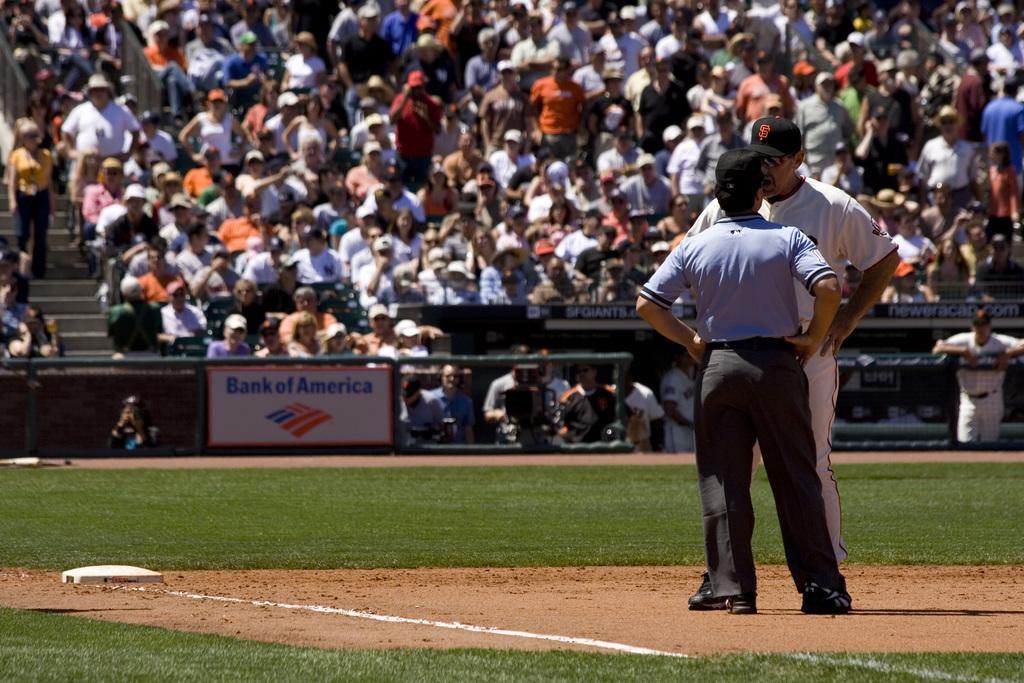How many people are standing on the right side of the image? There are two people standing on the right side of the image. What are the people wearing on their heads? The people are wearing caps. What can be seen in the background of the image? There is a crowd sitting in the background of the image, and a board is also visible. What type of rail can be seen in the image? There is no rail present in the image. How does the snow affect the people's clothing in the image? There is no snow present in the image, so it does not affect the people's clothing. 